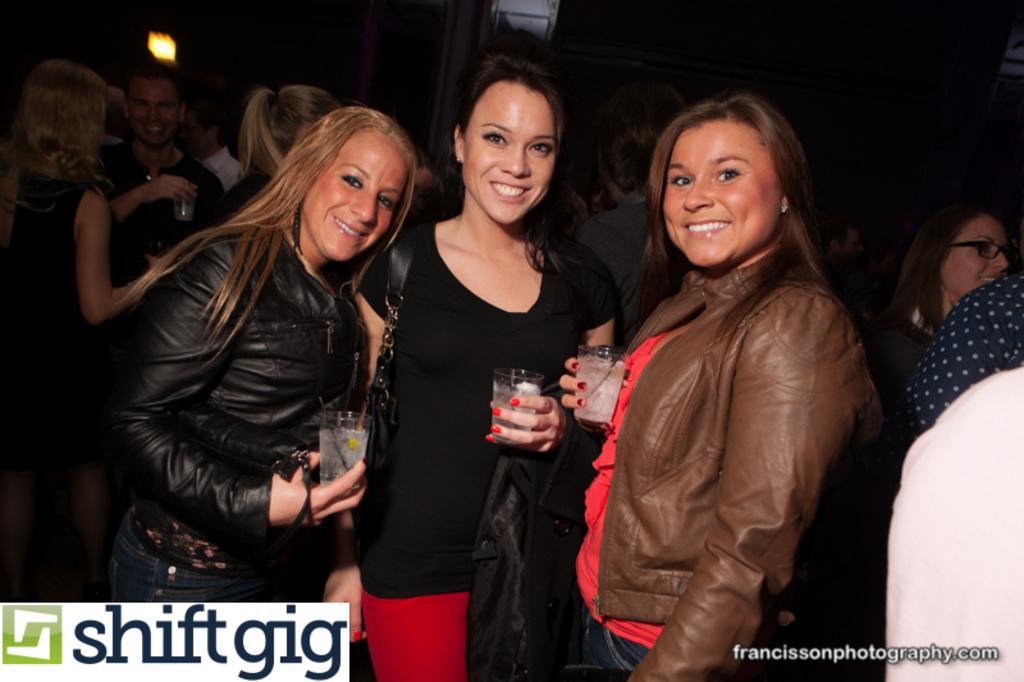Can you describe this image briefly? In this image we can see three women are standing. One woman is wearing red top with brown jacket and holding glass. The other woman is wearing black color t-shirt with red pant and carrying bag and holding glass. Third woman is wearing black color jacket with jeans and holding glass in her hand. At the bottom of the image, watermarks are there. Background of the image, people are present. 